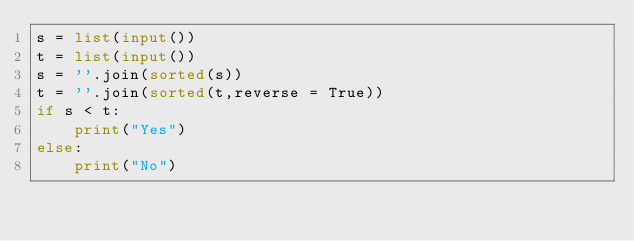<code> <loc_0><loc_0><loc_500><loc_500><_Python_>s = list(input())
t = list(input())
s = ''.join(sorted(s))
t = ''.join(sorted(t,reverse = True))
if s < t:
    print("Yes")
else:
    print("No")</code> 